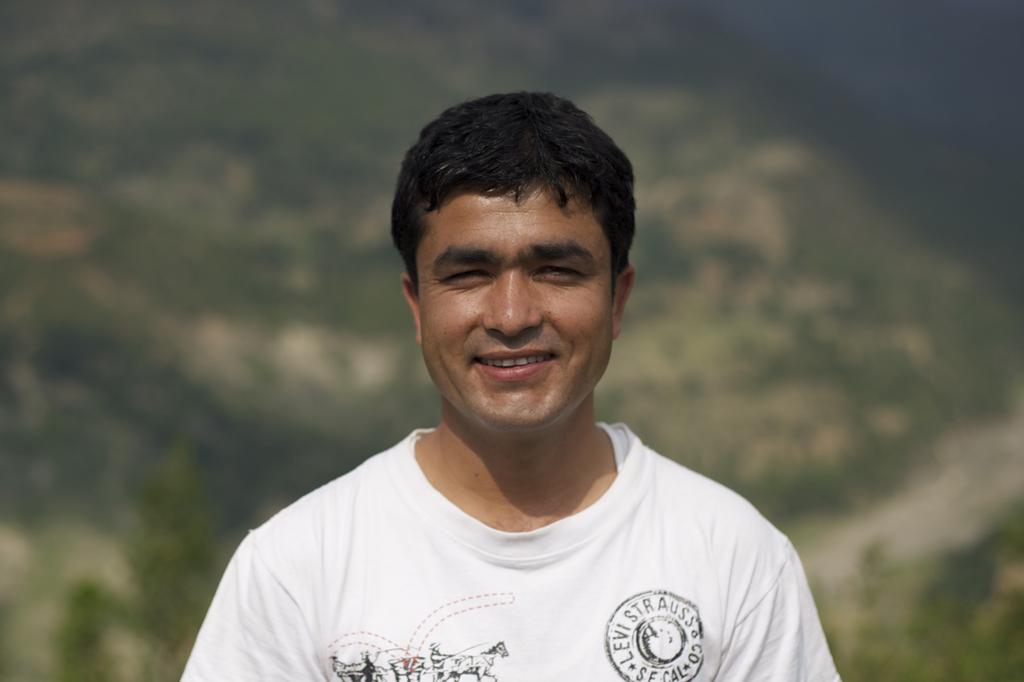What is the main subject of the image? There is a man in the image. What is the man's facial expression in the image? The man is smiling in the image. What type of picture is the man's aunt holding in the image? There is no mention of a picture or the man's aunt in the provided facts, so we cannot answer that question. 